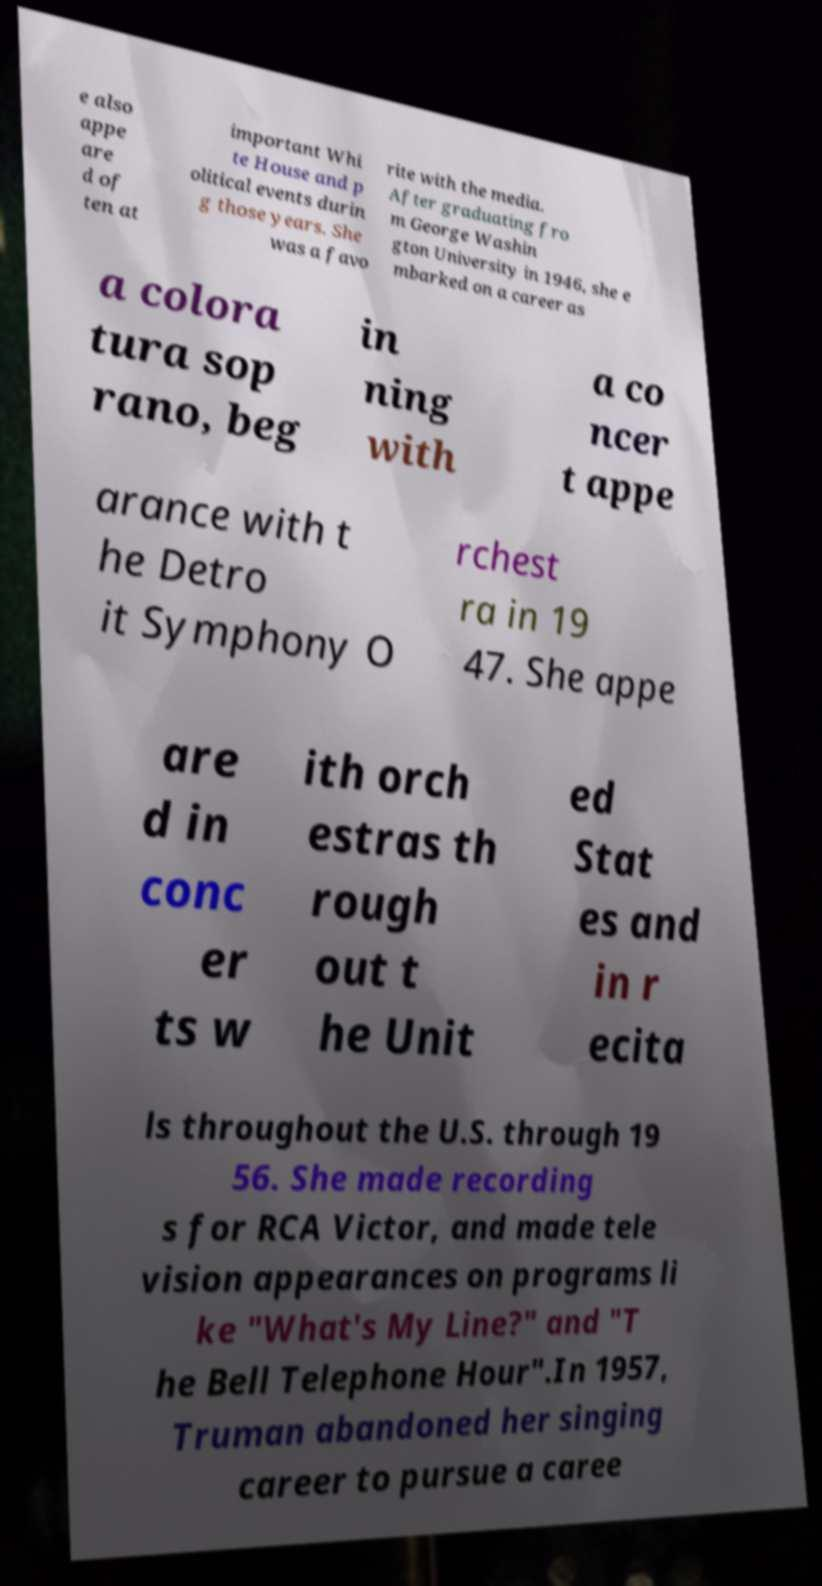Please identify and transcribe the text found in this image. e also appe are d of ten at important Whi te House and p olitical events durin g those years. She was a favo rite with the media. After graduating fro m George Washin gton University in 1946, she e mbarked on a career as a colora tura sop rano, beg in ning with a co ncer t appe arance with t he Detro it Symphony O rchest ra in 19 47. She appe are d in conc er ts w ith orch estras th rough out t he Unit ed Stat es and in r ecita ls throughout the U.S. through 19 56. She made recording s for RCA Victor, and made tele vision appearances on programs li ke "What's My Line?" and "T he Bell Telephone Hour".In 1957, Truman abandoned her singing career to pursue a caree 